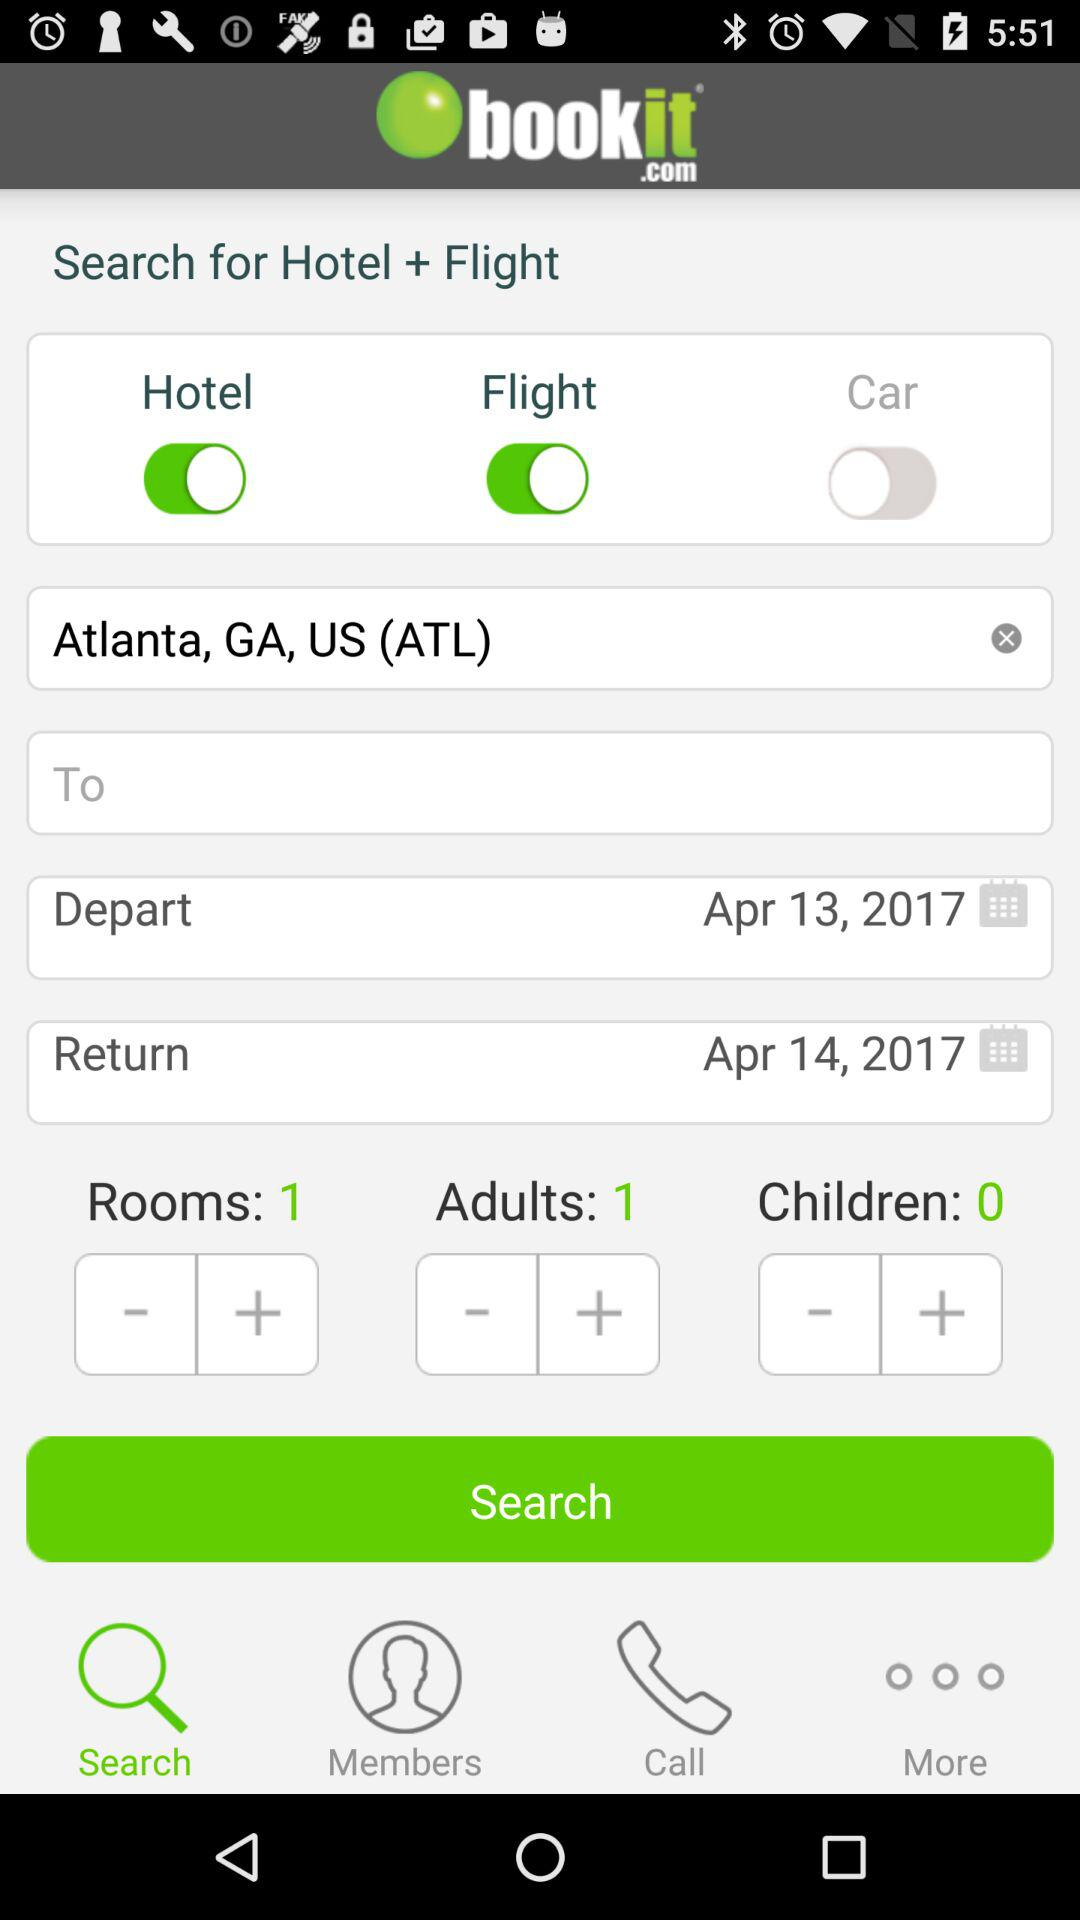How many adults are there? There is 1 adult. 